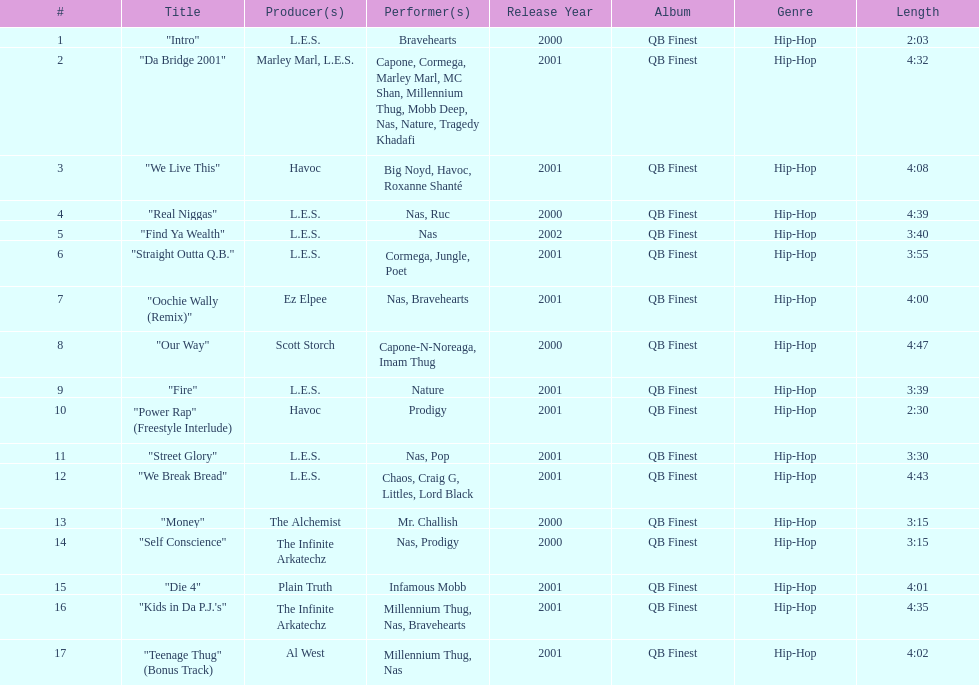Who created the last track on the album as its producer? Al West. 